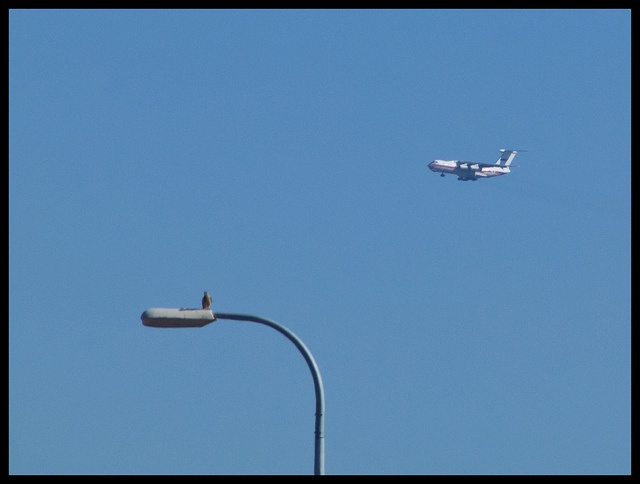Describe the objects in this image and their specific colors. I can see airplane in black, gray, blue, and lightgray tones and bird in black, gray, and navy tones in this image. 